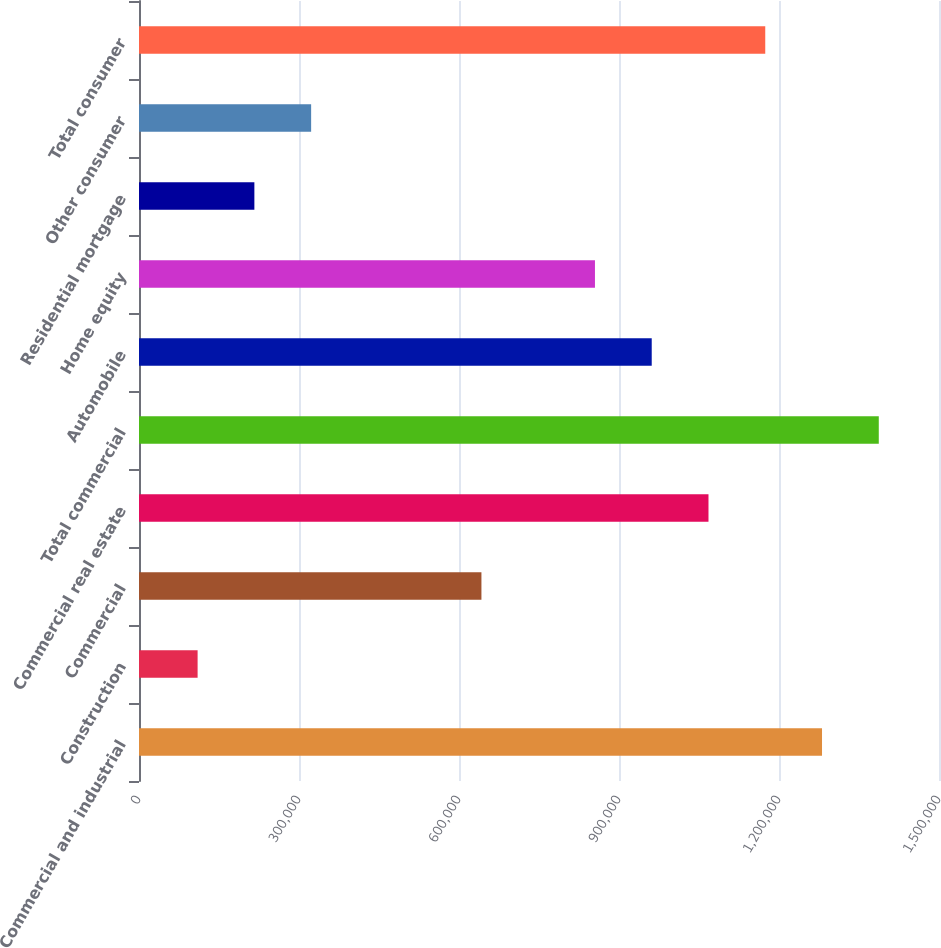Convert chart. <chart><loc_0><loc_0><loc_500><loc_500><bar_chart><fcel>Commercial and industrial<fcel>Construction<fcel>Commercial<fcel>Commercial real estate<fcel>Total commercial<fcel>Automobile<fcel>Home equity<fcel>Residential mortgage<fcel>Other consumer<fcel>Total consumer<nl><fcel>1.28066e+06<fcel>109889<fcel>642056<fcel>1.06779e+06<fcel>1.38709e+06<fcel>961356<fcel>854922<fcel>216323<fcel>322756<fcel>1.17422e+06<nl></chart> 